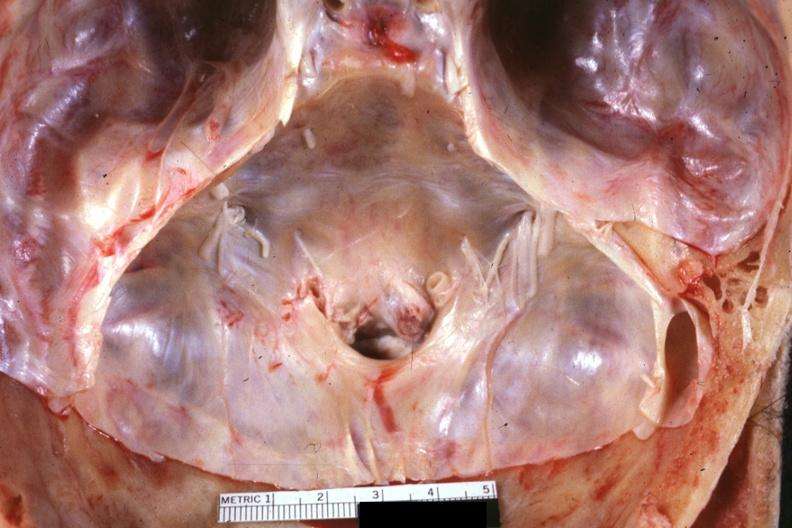does hematoma show stenotic foramen magnum in situs excellent example?
Answer the question using a single word or phrase. No 